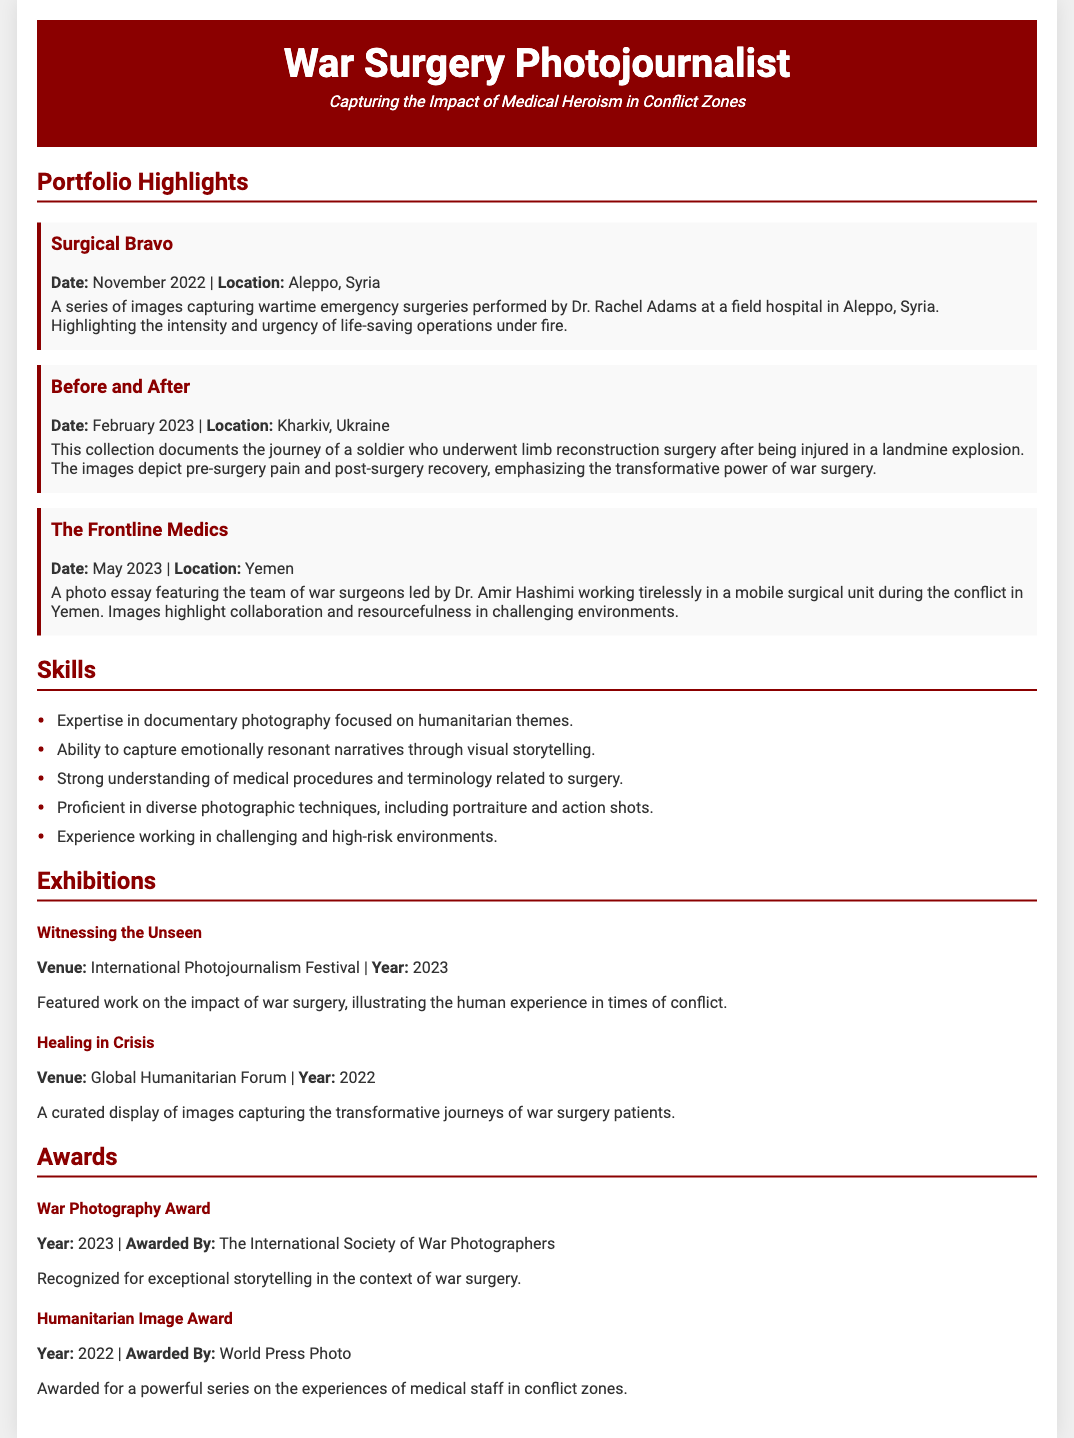what is the title of the resume? The title of the resume is prominently displayed at the top of the document.
Answer: War Surgery Photojournalist who performed the surgeries in Aleppo, Syria? The document mentions a specific surgeon's name associated with the surgeries in Aleppo.
Answer: Dr. Rachel Adams what was the date of the exhibition at the International Photojournalism Festival? This exhibition is listed with a specific year in the document.
Answer: 2023 what is a primary skill listed on the resume? The section on skills highlights specific competencies related to the photojournalist's work.
Answer: Expertise in documentary photography focused on humanitarian themes how many portfolio items are listed in the document? The portfolio section lists several individual projects, and the total is calculated based on how many are highlighted.
Answer: 3 what is the theme of the photo essay titled "The Frontline Medics"? The title suggests a focus area that the photo essay covers in detail.
Answer: Collaboration and resourcefulness in challenging environments who awarded the War Photography Award in 2023? The resume specifies the organization that granted this recognition, which is noted in the awards section.
Answer: The International Society of War Photographers 